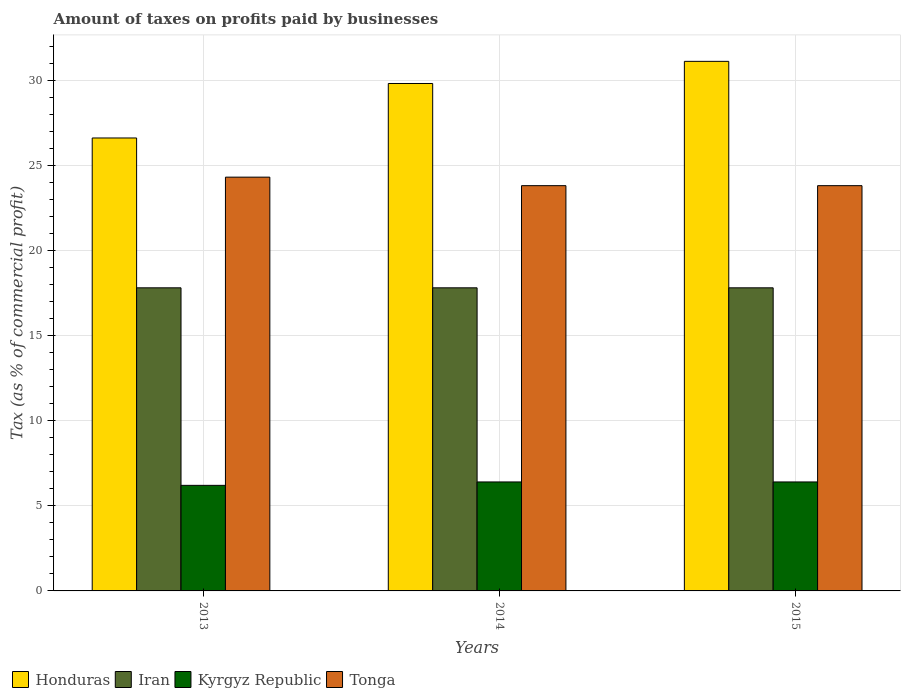How many different coloured bars are there?
Your answer should be compact. 4. How many bars are there on the 2nd tick from the right?
Your answer should be very brief. 4. What is the label of the 1st group of bars from the left?
Your answer should be very brief. 2013. Across all years, what is the maximum percentage of taxes paid by businesses in Honduras?
Offer a very short reply. 31.1. In which year was the percentage of taxes paid by businesses in Iran maximum?
Your answer should be very brief. 2013. What is the total percentage of taxes paid by businesses in Honduras in the graph?
Your answer should be very brief. 87.5. What is the difference between the percentage of taxes paid by businesses in Tonga in 2015 and the percentage of taxes paid by businesses in Honduras in 2013?
Your answer should be compact. -2.8. What is the average percentage of taxes paid by businesses in Iran per year?
Provide a short and direct response. 17.8. In the year 2013, what is the difference between the percentage of taxes paid by businesses in Honduras and percentage of taxes paid by businesses in Iran?
Provide a succinct answer. 8.8. Is the percentage of taxes paid by businesses in Iran in 2013 less than that in 2014?
Make the answer very short. No. Is the difference between the percentage of taxes paid by businesses in Honduras in 2014 and 2015 greater than the difference between the percentage of taxes paid by businesses in Iran in 2014 and 2015?
Keep it short and to the point. No. What is the difference between the highest and the second highest percentage of taxes paid by businesses in Honduras?
Your answer should be very brief. 1.3. Is the sum of the percentage of taxes paid by businesses in Tonga in 2014 and 2015 greater than the maximum percentage of taxes paid by businesses in Honduras across all years?
Provide a short and direct response. Yes. What does the 3rd bar from the left in 2013 represents?
Keep it short and to the point. Kyrgyz Republic. What does the 2nd bar from the right in 2013 represents?
Offer a terse response. Kyrgyz Republic. How many bars are there?
Ensure brevity in your answer.  12. How many years are there in the graph?
Your response must be concise. 3. What is the difference between two consecutive major ticks on the Y-axis?
Give a very brief answer. 5. Does the graph contain any zero values?
Your answer should be compact. No. How many legend labels are there?
Offer a terse response. 4. How are the legend labels stacked?
Your answer should be very brief. Horizontal. What is the title of the graph?
Your response must be concise. Amount of taxes on profits paid by businesses. What is the label or title of the X-axis?
Ensure brevity in your answer.  Years. What is the label or title of the Y-axis?
Offer a very short reply. Tax (as % of commercial profit). What is the Tax (as % of commercial profit) in Honduras in 2013?
Your answer should be compact. 26.6. What is the Tax (as % of commercial profit) of Iran in 2013?
Make the answer very short. 17.8. What is the Tax (as % of commercial profit) of Tonga in 2013?
Your response must be concise. 24.3. What is the Tax (as % of commercial profit) of Honduras in 2014?
Make the answer very short. 29.8. What is the Tax (as % of commercial profit) of Tonga in 2014?
Your response must be concise. 23.8. What is the Tax (as % of commercial profit) of Honduras in 2015?
Offer a terse response. 31.1. What is the Tax (as % of commercial profit) in Iran in 2015?
Offer a terse response. 17.8. What is the Tax (as % of commercial profit) of Kyrgyz Republic in 2015?
Your answer should be very brief. 6.4. What is the Tax (as % of commercial profit) in Tonga in 2015?
Provide a short and direct response. 23.8. Across all years, what is the maximum Tax (as % of commercial profit) in Honduras?
Ensure brevity in your answer.  31.1. Across all years, what is the maximum Tax (as % of commercial profit) of Iran?
Offer a very short reply. 17.8. Across all years, what is the maximum Tax (as % of commercial profit) in Tonga?
Ensure brevity in your answer.  24.3. Across all years, what is the minimum Tax (as % of commercial profit) in Honduras?
Make the answer very short. 26.6. Across all years, what is the minimum Tax (as % of commercial profit) of Iran?
Provide a short and direct response. 17.8. Across all years, what is the minimum Tax (as % of commercial profit) of Kyrgyz Republic?
Provide a short and direct response. 6.2. Across all years, what is the minimum Tax (as % of commercial profit) in Tonga?
Your answer should be compact. 23.8. What is the total Tax (as % of commercial profit) of Honduras in the graph?
Ensure brevity in your answer.  87.5. What is the total Tax (as % of commercial profit) of Iran in the graph?
Keep it short and to the point. 53.4. What is the total Tax (as % of commercial profit) in Kyrgyz Republic in the graph?
Your answer should be very brief. 19. What is the total Tax (as % of commercial profit) in Tonga in the graph?
Give a very brief answer. 71.9. What is the difference between the Tax (as % of commercial profit) of Honduras in 2013 and that in 2014?
Your response must be concise. -3.2. What is the difference between the Tax (as % of commercial profit) in Kyrgyz Republic in 2013 and that in 2014?
Make the answer very short. -0.2. What is the difference between the Tax (as % of commercial profit) in Iran in 2013 and that in 2015?
Offer a terse response. 0. What is the difference between the Tax (as % of commercial profit) in Kyrgyz Republic in 2013 and that in 2015?
Give a very brief answer. -0.2. What is the difference between the Tax (as % of commercial profit) in Kyrgyz Republic in 2014 and that in 2015?
Make the answer very short. 0. What is the difference between the Tax (as % of commercial profit) in Tonga in 2014 and that in 2015?
Keep it short and to the point. 0. What is the difference between the Tax (as % of commercial profit) in Honduras in 2013 and the Tax (as % of commercial profit) in Kyrgyz Republic in 2014?
Offer a very short reply. 20.2. What is the difference between the Tax (as % of commercial profit) in Honduras in 2013 and the Tax (as % of commercial profit) in Tonga in 2014?
Offer a very short reply. 2.8. What is the difference between the Tax (as % of commercial profit) in Kyrgyz Republic in 2013 and the Tax (as % of commercial profit) in Tonga in 2014?
Keep it short and to the point. -17.6. What is the difference between the Tax (as % of commercial profit) of Honduras in 2013 and the Tax (as % of commercial profit) of Iran in 2015?
Offer a very short reply. 8.8. What is the difference between the Tax (as % of commercial profit) of Honduras in 2013 and the Tax (as % of commercial profit) of Kyrgyz Republic in 2015?
Make the answer very short. 20.2. What is the difference between the Tax (as % of commercial profit) of Iran in 2013 and the Tax (as % of commercial profit) of Kyrgyz Republic in 2015?
Offer a very short reply. 11.4. What is the difference between the Tax (as % of commercial profit) of Iran in 2013 and the Tax (as % of commercial profit) of Tonga in 2015?
Make the answer very short. -6. What is the difference between the Tax (as % of commercial profit) in Kyrgyz Republic in 2013 and the Tax (as % of commercial profit) in Tonga in 2015?
Keep it short and to the point. -17.6. What is the difference between the Tax (as % of commercial profit) of Honduras in 2014 and the Tax (as % of commercial profit) of Iran in 2015?
Your answer should be compact. 12. What is the difference between the Tax (as % of commercial profit) of Honduras in 2014 and the Tax (as % of commercial profit) of Kyrgyz Republic in 2015?
Keep it short and to the point. 23.4. What is the difference between the Tax (as % of commercial profit) in Honduras in 2014 and the Tax (as % of commercial profit) in Tonga in 2015?
Offer a very short reply. 6. What is the difference between the Tax (as % of commercial profit) of Iran in 2014 and the Tax (as % of commercial profit) of Kyrgyz Republic in 2015?
Offer a terse response. 11.4. What is the difference between the Tax (as % of commercial profit) of Iran in 2014 and the Tax (as % of commercial profit) of Tonga in 2015?
Offer a very short reply. -6. What is the difference between the Tax (as % of commercial profit) in Kyrgyz Republic in 2014 and the Tax (as % of commercial profit) in Tonga in 2015?
Your answer should be compact. -17.4. What is the average Tax (as % of commercial profit) in Honduras per year?
Ensure brevity in your answer.  29.17. What is the average Tax (as % of commercial profit) in Iran per year?
Offer a very short reply. 17.8. What is the average Tax (as % of commercial profit) in Kyrgyz Republic per year?
Give a very brief answer. 6.33. What is the average Tax (as % of commercial profit) of Tonga per year?
Provide a short and direct response. 23.97. In the year 2013, what is the difference between the Tax (as % of commercial profit) of Honduras and Tax (as % of commercial profit) of Kyrgyz Republic?
Your answer should be very brief. 20.4. In the year 2013, what is the difference between the Tax (as % of commercial profit) in Iran and Tax (as % of commercial profit) in Kyrgyz Republic?
Your response must be concise. 11.6. In the year 2013, what is the difference between the Tax (as % of commercial profit) in Kyrgyz Republic and Tax (as % of commercial profit) in Tonga?
Your response must be concise. -18.1. In the year 2014, what is the difference between the Tax (as % of commercial profit) in Honduras and Tax (as % of commercial profit) in Iran?
Ensure brevity in your answer.  12. In the year 2014, what is the difference between the Tax (as % of commercial profit) of Honduras and Tax (as % of commercial profit) of Kyrgyz Republic?
Your answer should be compact. 23.4. In the year 2014, what is the difference between the Tax (as % of commercial profit) in Honduras and Tax (as % of commercial profit) in Tonga?
Your response must be concise. 6. In the year 2014, what is the difference between the Tax (as % of commercial profit) of Iran and Tax (as % of commercial profit) of Tonga?
Your answer should be very brief. -6. In the year 2014, what is the difference between the Tax (as % of commercial profit) of Kyrgyz Republic and Tax (as % of commercial profit) of Tonga?
Ensure brevity in your answer.  -17.4. In the year 2015, what is the difference between the Tax (as % of commercial profit) of Honduras and Tax (as % of commercial profit) of Kyrgyz Republic?
Your answer should be compact. 24.7. In the year 2015, what is the difference between the Tax (as % of commercial profit) of Iran and Tax (as % of commercial profit) of Kyrgyz Republic?
Your answer should be compact. 11.4. In the year 2015, what is the difference between the Tax (as % of commercial profit) of Iran and Tax (as % of commercial profit) of Tonga?
Provide a short and direct response. -6. In the year 2015, what is the difference between the Tax (as % of commercial profit) of Kyrgyz Republic and Tax (as % of commercial profit) of Tonga?
Keep it short and to the point. -17.4. What is the ratio of the Tax (as % of commercial profit) in Honduras in 2013 to that in 2014?
Your answer should be very brief. 0.89. What is the ratio of the Tax (as % of commercial profit) in Iran in 2013 to that in 2014?
Provide a succinct answer. 1. What is the ratio of the Tax (as % of commercial profit) of Kyrgyz Republic in 2013 to that in 2014?
Your answer should be compact. 0.97. What is the ratio of the Tax (as % of commercial profit) of Honduras in 2013 to that in 2015?
Ensure brevity in your answer.  0.86. What is the ratio of the Tax (as % of commercial profit) in Kyrgyz Republic in 2013 to that in 2015?
Offer a very short reply. 0.97. What is the ratio of the Tax (as % of commercial profit) of Tonga in 2013 to that in 2015?
Make the answer very short. 1.02. What is the ratio of the Tax (as % of commercial profit) in Honduras in 2014 to that in 2015?
Keep it short and to the point. 0.96. What is the ratio of the Tax (as % of commercial profit) of Iran in 2014 to that in 2015?
Your response must be concise. 1. What is the ratio of the Tax (as % of commercial profit) in Tonga in 2014 to that in 2015?
Ensure brevity in your answer.  1. What is the difference between the highest and the second highest Tax (as % of commercial profit) of Honduras?
Your answer should be very brief. 1.3. What is the difference between the highest and the second highest Tax (as % of commercial profit) of Iran?
Your response must be concise. 0. What is the difference between the highest and the lowest Tax (as % of commercial profit) of Honduras?
Provide a succinct answer. 4.5. What is the difference between the highest and the lowest Tax (as % of commercial profit) in Kyrgyz Republic?
Your response must be concise. 0.2. 